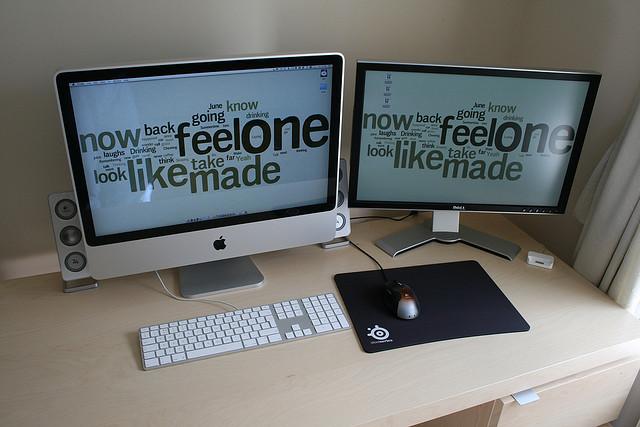Are there red letters?
Concise answer only. No. What is the object on the window sill?
Answer briefly. Curtain. What is the last word on the note?
Give a very brief answer. Made. What brand is the electronic device?
Write a very short answer. Apple. Is there a laptop computer on the right?
Give a very brief answer. No. What color is the mouse pad?
Write a very short answer. Black. Are these electronics all the same brand?
Give a very brief answer. No. Is that a desktop computer or a laptop?
Short answer required. Desktop. Can you see a cell phone on the desk?
Be succinct. No. Do these computers look old?
Write a very short answer. No. What color is the desk?
Concise answer only. White. Who is in the photo?
Be succinct. Nobody. How many devices are in black and white?
Concise answer only. 2. Would someone be likely to have their eyesight harmed by looking at the screens?
Be succinct. No. What is in the picture?
Give a very brief answer. Computers. Are there blue letters?
Quick response, please. No. What does the mouse pad look like?
Give a very brief answer. Black. What brand is the computer?
Quick response, please. Apple. What electronic device is this?
Write a very short answer. Computer. 